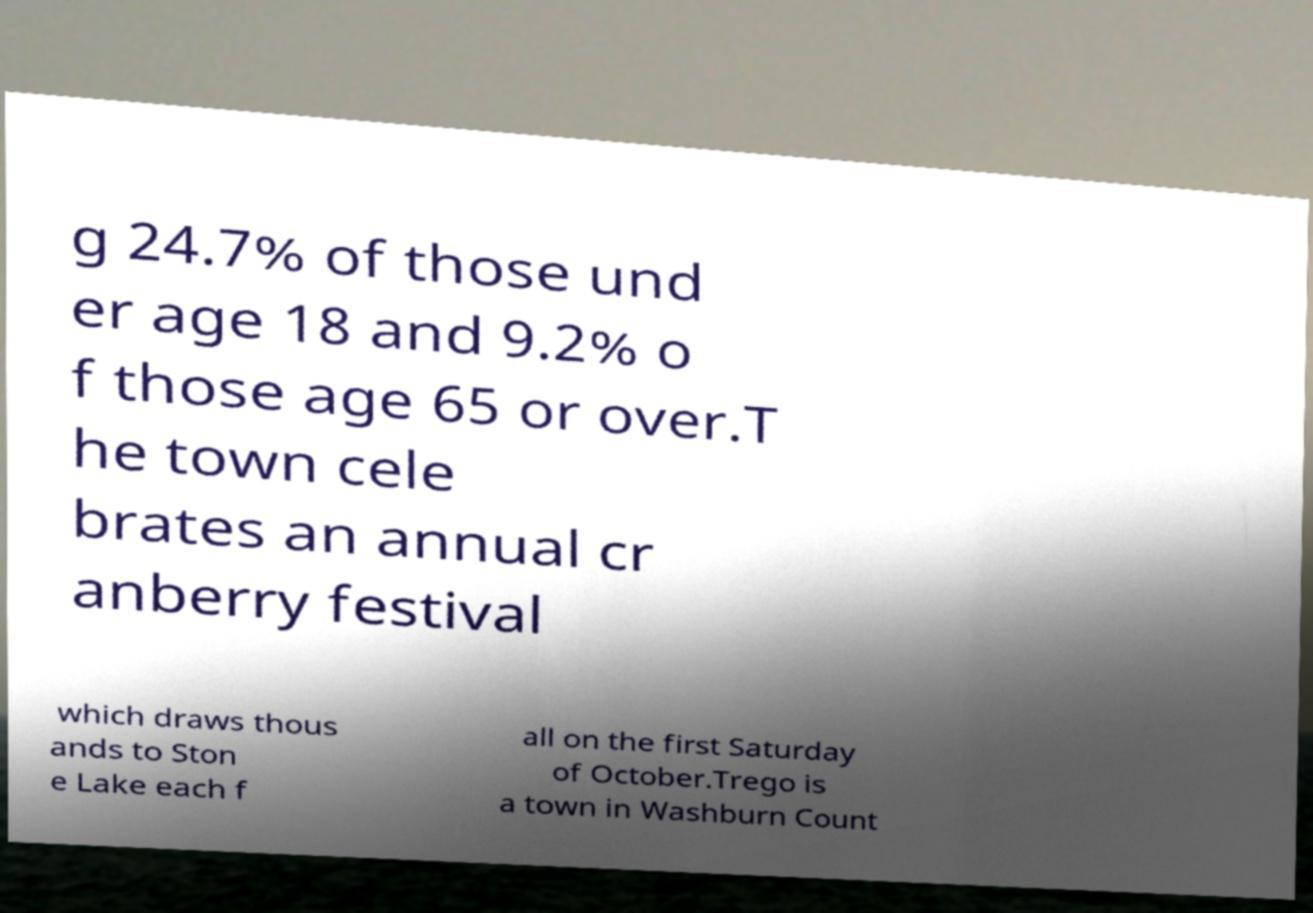For documentation purposes, I need the text within this image transcribed. Could you provide that? g 24.7% of those und er age 18 and 9.2% o f those age 65 or over.T he town cele brates an annual cr anberry festival which draws thous ands to Ston e Lake each f all on the first Saturday of October.Trego is a town in Washburn Count 